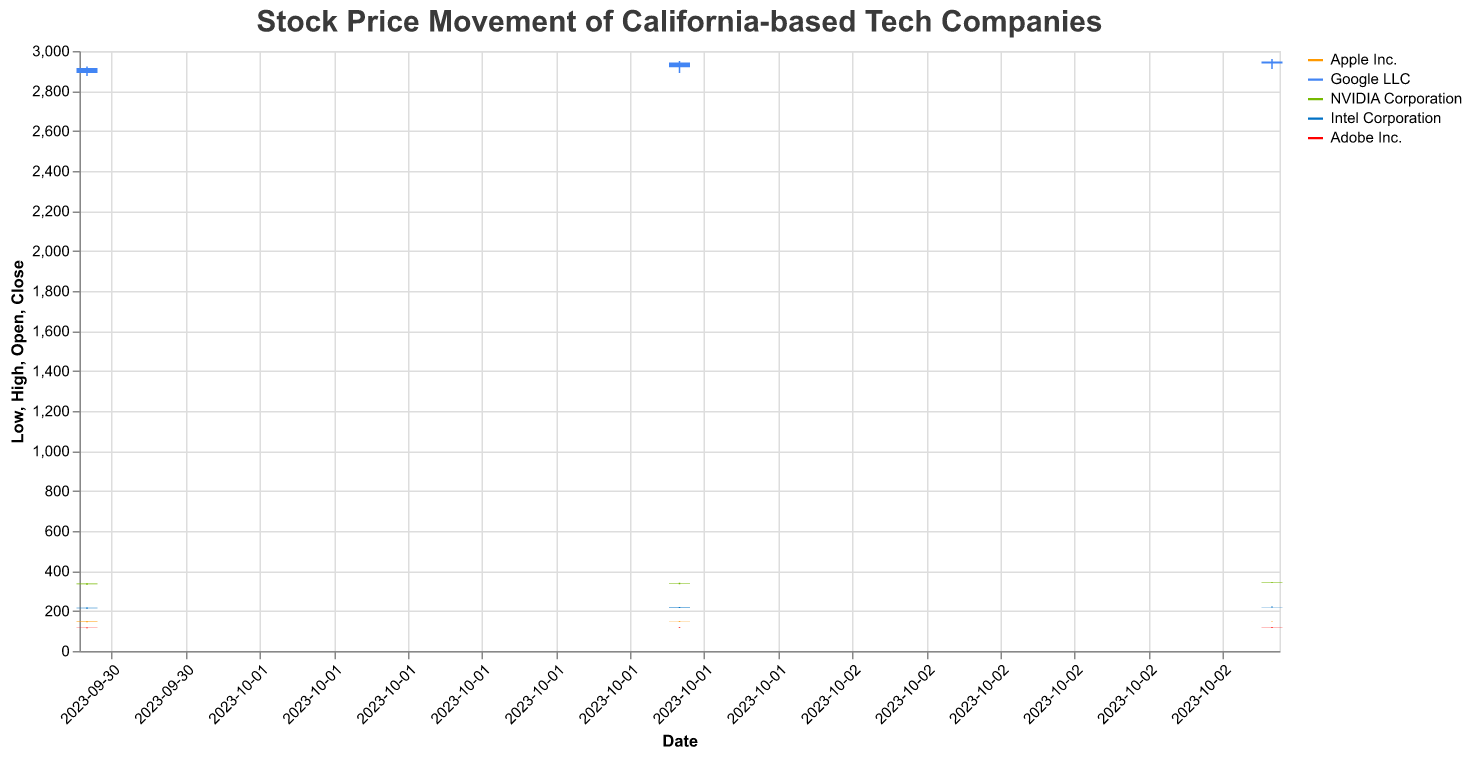What is the title of the plot? The title is displayed at the top of the plot, summarizing the content. It reads "Stock Price Movement of California-based Tech Companies".
Answer: Stock Price Movement of California-based Tech Companies What is the highest stock price for Google LLC during the given dates? The highest stock price for Google LLC can be observed by looking at the "High" values for Google LLC over the given dates. The highest value is 2960.00 on 2023-10-03.
Answer: 2960.00 For which company and on what date did the stock price close highest? By comparing the "Close" prices for all companies and dates, the highest close price was for Google LLC on 2023-10-02 with a close of 2942.80.
Answer: Google LLC on 2023-10-02 Which company's stock had the smallest range between the highest and lowest prices on 2023-10-01? To find the smallest range, calculate the difference between "High" and "Low" prices for each company on 2023-10-01. Adobe Inc. had the smallest range with (118.00 - 113.25) = 4.75.
Answer: Adobe Inc How did Intel Corporation's opening price on 2023-10-03 compare to its closing price on 2023-10-02? For Intel Corporation, the opening price on 2023-10-03 was 219.00 and the closing price on 2023-10-02 was 218.75. Thus, the opening price on 2023-10-03 was higher by 0.25.
Answer: 0.25 higher What was the average closing price of Apple Inc. over the three days? Sum the closing prices of Apple Inc. over the dates (147.75 + 148.20 + 149.25) and divide by 3. (147.75 + 148.20 + 149.25) / 3 = 148.40.
Answer: 148.40 Which company had the highest trading volume on 2023-10-02? By checking the "Volume" values for each company on 2023-10-02, Apple Inc. had the highest volume with 3,152,800 shares traded.
Answer: Apple Inc Compare the closing prices of Adobe Inc. on 2023-10-01 and 2023-10-03. How much did it change? The closing price for Adobe Inc. on 2023-10-01 was 116.75 and on 2023-10-03 was 119.25. The change is calculated as 119.25 - 116.75 = 2.50.
Answer: 2.50 increase Which company had the largest increase in closing price from 2023-10-01 to 2023-10-02? Calculate the difference in closing prices from 2023-10-01 to 2023-10-02 for each company. The largest increase was for Intel Corporation, which went from 216.25 to 218.75, an increase of 2.50.
Answer: Intel Corporation What was Apple's lowest stock price across the three days? Check the "Low" values for Apple Inc. across the three days. The lowest price was 144.11 on 2023-10-01.
Answer: 144.11 